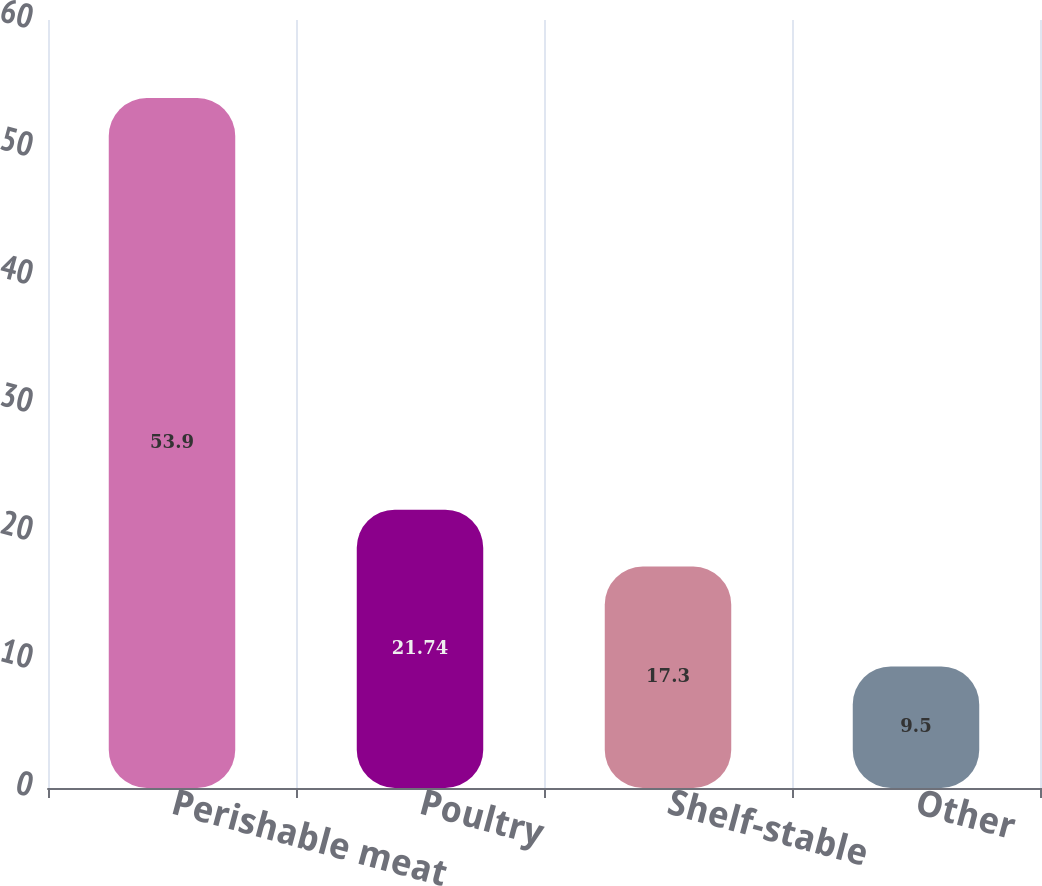Convert chart. <chart><loc_0><loc_0><loc_500><loc_500><bar_chart><fcel>Perishable meat<fcel>Poultry<fcel>Shelf-stable<fcel>Other<nl><fcel>53.9<fcel>21.74<fcel>17.3<fcel>9.5<nl></chart> 